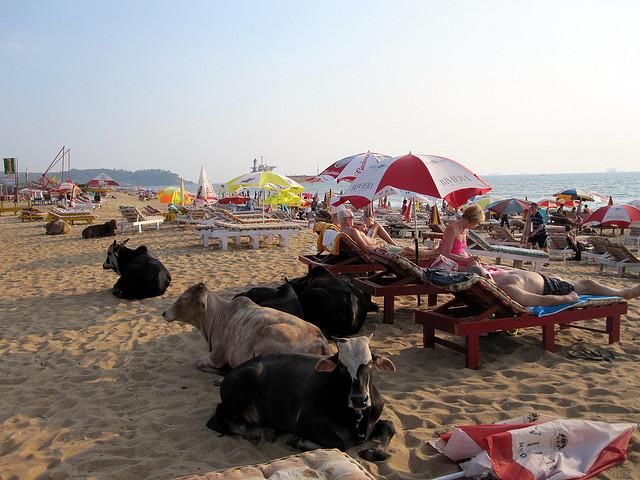What kind of animal is on the beach?
Quick response, please. Cow. How many umbrellas are pictured?
Short answer required. 10. What appears out of place on this beach?
Quick response, please. Cows. 